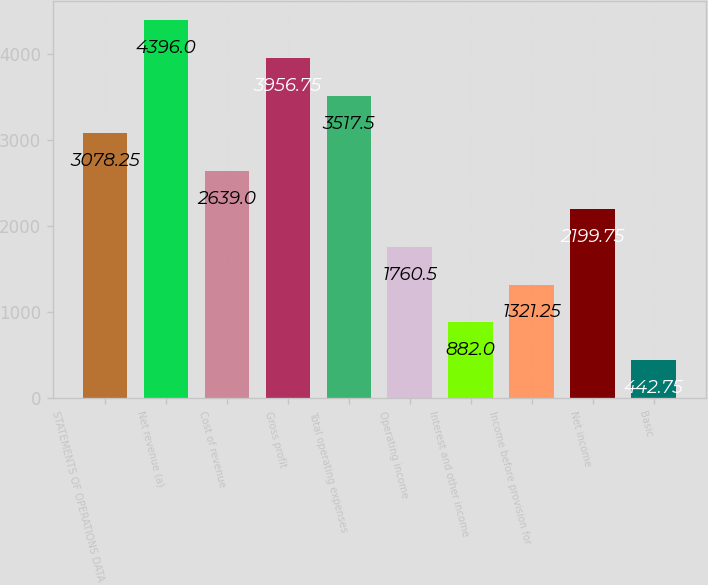Convert chart. <chart><loc_0><loc_0><loc_500><loc_500><bar_chart><fcel>STATEMENTS OF OPERATIONS DATA<fcel>Net revenue (a)<fcel>Cost of revenue<fcel>Gross profit<fcel>Total operating expenses<fcel>Operating income<fcel>Interest and other income<fcel>Income before provision for<fcel>Net income<fcel>Basic<nl><fcel>3078.25<fcel>4396<fcel>2639<fcel>3956.75<fcel>3517.5<fcel>1760.5<fcel>882<fcel>1321.25<fcel>2199.75<fcel>442.75<nl></chart> 